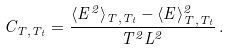<formula> <loc_0><loc_0><loc_500><loc_500>C _ { T , T _ { t } } = \frac { \langle E ^ { 2 } \rangle _ { T , T _ { t } } - \langle E \rangle ^ { 2 } _ { T , T _ { t } } } { T ^ { 2 } L ^ { 2 } } \, .</formula> 